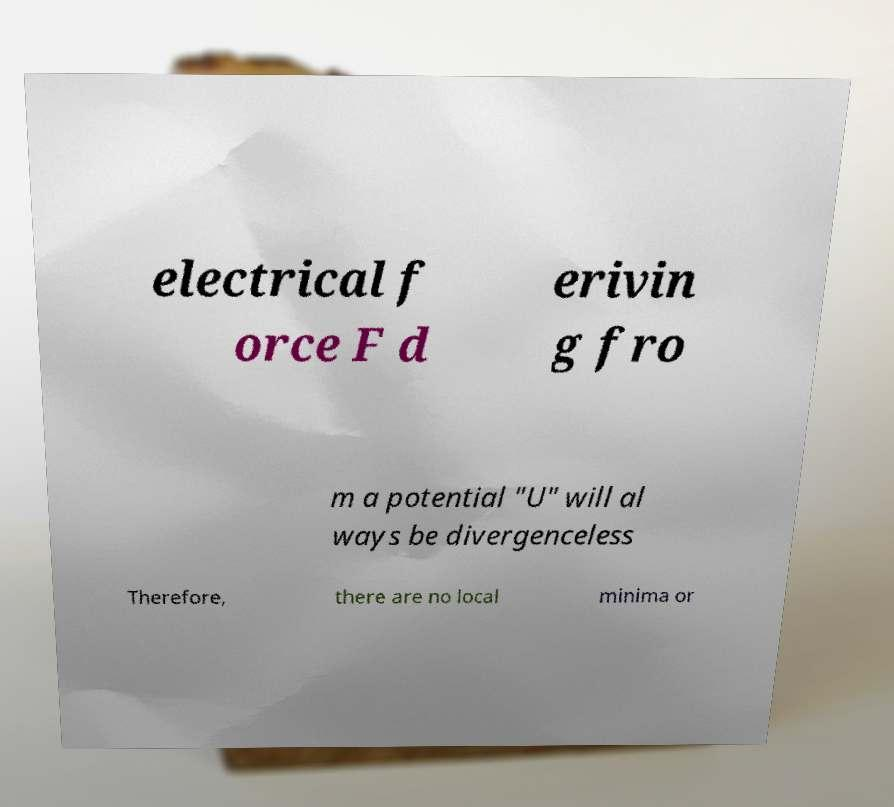Please identify and transcribe the text found in this image. electrical f orce F d erivin g fro m a potential "U" will al ways be divergenceless Therefore, there are no local minima or 